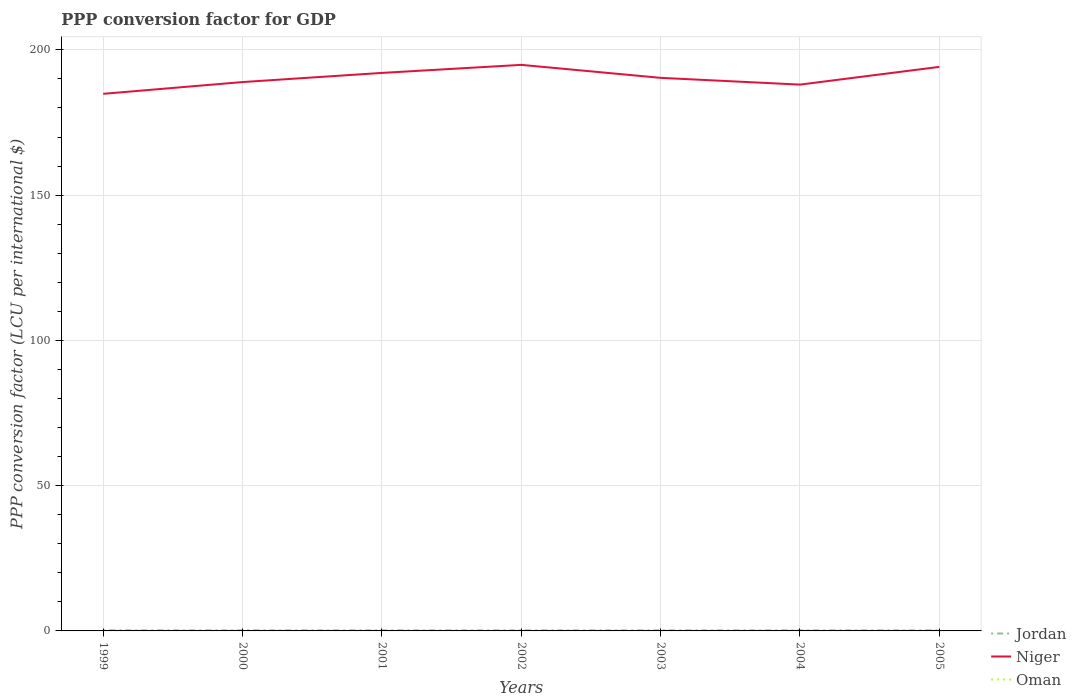How many different coloured lines are there?
Your response must be concise. 3. Is the number of lines equal to the number of legend labels?
Offer a terse response. Yes. Across all years, what is the maximum PPP conversion factor for GDP in Jordan?
Keep it short and to the point. 0.2. In which year was the PPP conversion factor for GDP in Niger maximum?
Offer a very short reply. 1999. What is the total PPP conversion factor for GDP in Niger in the graph?
Make the answer very short. -5.92. What is the difference between the highest and the second highest PPP conversion factor for GDP in Oman?
Make the answer very short. 0.05. Is the PPP conversion factor for GDP in Jordan strictly greater than the PPP conversion factor for GDP in Niger over the years?
Provide a succinct answer. Yes. Are the values on the major ticks of Y-axis written in scientific E-notation?
Ensure brevity in your answer.  No. Where does the legend appear in the graph?
Keep it short and to the point. Bottom right. How many legend labels are there?
Give a very brief answer. 3. How are the legend labels stacked?
Your response must be concise. Vertical. What is the title of the graph?
Provide a short and direct response. PPP conversion factor for GDP. Does "Aruba" appear as one of the legend labels in the graph?
Make the answer very short. No. What is the label or title of the X-axis?
Your answer should be compact. Years. What is the label or title of the Y-axis?
Keep it short and to the point. PPP conversion factor (LCU per international $). What is the PPP conversion factor (LCU per international $) in Jordan in 1999?
Provide a short and direct response. 0.21. What is the PPP conversion factor (LCU per international $) of Niger in 1999?
Ensure brevity in your answer.  184.87. What is the PPP conversion factor (LCU per international $) in Oman in 1999?
Ensure brevity in your answer.  0.08. What is the PPP conversion factor (LCU per international $) in Jordan in 2000?
Provide a short and direct response. 0.2. What is the PPP conversion factor (LCU per international $) in Niger in 2000?
Keep it short and to the point. 188.91. What is the PPP conversion factor (LCU per international $) in Oman in 2000?
Keep it short and to the point. 0.09. What is the PPP conversion factor (LCU per international $) of Jordan in 2001?
Your response must be concise. 0.2. What is the PPP conversion factor (LCU per international $) in Niger in 2001?
Offer a terse response. 192.06. What is the PPP conversion factor (LCU per international $) of Oman in 2001?
Provide a short and direct response. 0.09. What is the PPP conversion factor (LCU per international $) in Jordan in 2002?
Keep it short and to the point. 0.2. What is the PPP conversion factor (LCU per international $) of Niger in 2002?
Offer a very short reply. 194.83. What is the PPP conversion factor (LCU per international $) in Oman in 2002?
Offer a terse response. 0.09. What is the PPP conversion factor (LCU per international $) in Jordan in 2003?
Provide a succinct answer. 0.2. What is the PPP conversion factor (LCU per international $) in Niger in 2003?
Your answer should be very brief. 190.36. What is the PPP conversion factor (LCU per international $) of Oman in 2003?
Provide a short and direct response. 0.1. What is the PPP conversion factor (LCU per international $) in Jordan in 2004?
Your response must be concise. 0.2. What is the PPP conversion factor (LCU per international $) of Niger in 2004?
Give a very brief answer. 188.03. What is the PPP conversion factor (LCU per international $) in Oman in 2004?
Make the answer very short. 0.11. What is the PPP conversion factor (LCU per international $) of Jordan in 2005?
Your response must be concise. 0.2. What is the PPP conversion factor (LCU per international $) of Niger in 2005?
Ensure brevity in your answer.  194.14. What is the PPP conversion factor (LCU per international $) of Oman in 2005?
Ensure brevity in your answer.  0.13. Across all years, what is the maximum PPP conversion factor (LCU per international $) in Jordan?
Give a very brief answer. 0.21. Across all years, what is the maximum PPP conversion factor (LCU per international $) in Niger?
Keep it short and to the point. 194.83. Across all years, what is the maximum PPP conversion factor (LCU per international $) in Oman?
Your answer should be compact. 0.13. Across all years, what is the minimum PPP conversion factor (LCU per international $) in Jordan?
Provide a succinct answer. 0.2. Across all years, what is the minimum PPP conversion factor (LCU per international $) of Niger?
Ensure brevity in your answer.  184.87. Across all years, what is the minimum PPP conversion factor (LCU per international $) in Oman?
Make the answer very short. 0.08. What is the total PPP conversion factor (LCU per international $) in Jordan in the graph?
Offer a very short reply. 1.42. What is the total PPP conversion factor (LCU per international $) of Niger in the graph?
Provide a succinct answer. 1333.21. What is the total PPP conversion factor (LCU per international $) in Oman in the graph?
Your response must be concise. 0.69. What is the difference between the PPP conversion factor (LCU per international $) of Jordan in 1999 and that in 2000?
Provide a short and direct response. 0.01. What is the difference between the PPP conversion factor (LCU per international $) in Niger in 1999 and that in 2000?
Offer a very short reply. -4.05. What is the difference between the PPP conversion factor (LCU per international $) in Oman in 1999 and that in 2000?
Make the answer very short. -0.01. What is the difference between the PPP conversion factor (LCU per international $) of Jordan in 1999 and that in 2001?
Keep it short and to the point. 0.01. What is the difference between the PPP conversion factor (LCU per international $) in Niger in 1999 and that in 2001?
Offer a very short reply. -7.2. What is the difference between the PPP conversion factor (LCU per international $) in Oman in 1999 and that in 2001?
Your answer should be very brief. -0.01. What is the difference between the PPP conversion factor (LCU per international $) in Jordan in 1999 and that in 2002?
Your response must be concise. 0.01. What is the difference between the PPP conversion factor (LCU per international $) of Niger in 1999 and that in 2002?
Ensure brevity in your answer.  -9.96. What is the difference between the PPP conversion factor (LCU per international $) in Oman in 1999 and that in 2002?
Make the answer very short. -0.01. What is the difference between the PPP conversion factor (LCU per international $) in Jordan in 1999 and that in 2003?
Provide a succinct answer. 0.01. What is the difference between the PPP conversion factor (LCU per international $) of Niger in 1999 and that in 2003?
Give a very brief answer. -5.5. What is the difference between the PPP conversion factor (LCU per international $) of Oman in 1999 and that in 2003?
Provide a succinct answer. -0.02. What is the difference between the PPP conversion factor (LCU per international $) of Jordan in 1999 and that in 2004?
Your answer should be compact. 0.01. What is the difference between the PPP conversion factor (LCU per international $) in Niger in 1999 and that in 2004?
Provide a succinct answer. -3.17. What is the difference between the PPP conversion factor (LCU per international $) of Oman in 1999 and that in 2004?
Keep it short and to the point. -0.03. What is the difference between the PPP conversion factor (LCU per international $) of Jordan in 1999 and that in 2005?
Your response must be concise. 0.01. What is the difference between the PPP conversion factor (LCU per international $) in Niger in 1999 and that in 2005?
Keep it short and to the point. -9.28. What is the difference between the PPP conversion factor (LCU per international $) in Oman in 1999 and that in 2005?
Provide a short and direct response. -0.05. What is the difference between the PPP conversion factor (LCU per international $) of Jordan in 2000 and that in 2001?
Give a very brief answer. 0. What is the difference between the PPP conversion factor (LCU per international $) in Niger in 2000 and that in 2001?
Your answer should be compact. -3.15. What is the difference between the PPP conversion factor (LCU per international $) of Oman in 2000 and that in 2001?
Keep it short and to the point. 0.01. What is the difference between the PPP conversion factor (LCU per international $) in Jordan in 2000 and that in 2002?
Provide a short and direct response. 0. What is the difference between the PPP conversion factor (LCU per international $) of Niger in 2000 and that in 2002?
Your answer should be compact. -5.92. What is the difference between the PPP conversion factor (LCU per international $) of Oman in 2000 and that in 2002?
Make the answer very short. 0. What is the difference between the PPP conversion factor (LCU per international $) in Jordan in 2000 and that in 2003?
Your answer should be very brief. 0. What is the difference between the PPP conversion factor (LCU per international $) of Niger in 2000 and that in 2003?
Provide a short and direct response. -1.45. What is the difference between the PPP conversion factor (LCU per international $) of Oman in 2000 and that in 2003?
Offer a terse response. -0. What is the difference between the PPP conversion factor (LCU per international $) in Jordan in 2000 and that in 2004?
Ensure brevity in your answer.  0. What is the difference between the PPP conversion factor (LCU per international $) in Niger in 2000 and that in 2004?
Ensure brevity in your answer.  0.88. What is the difference between the PPP conversion factor (LCU per international $) in Oman in 2000 and that in 2004?
Offer a very short reply. -0.01. What is the difference between the PPP conversion factor (LCU per international $) of Jordan in 2000 and that in 2005?
Provide a short and direct response. 0.01. What is the difference between the PPP conversion factor (LCU per international $) of Niger in 2000 and that in 2005?
Keep it short and to the point. -5.23. What is the difference between the PPP conversion factor (LCU per international $) in Oman in 2000 and that in 2005?
Give a very brief answer. -0.03. What is the difference between the PPP conversion factor (LCU per international $) in Jordan in 2001 and that in 2002?
Ensure brevity in your answer.  0. What is the difference between the PPP conversion factor (LCU per international $) of Niger in 2001 and that in 2002?
Your answer should be very brief. -2.77. What is the difference between the PPP conversion factor (LCU per international $) of Oman in 2001 and that in 2002?
Provide a short and direct response. -0. What is the difference between the PPP conversion factor (LCU per international $) of Jordan in 2001 and that in 2003?
Ensure brevity in your answer.  0. What is the difference between the PPP conversion factor (LCU per international $) in Niger in 2001 and that in 2003?
Offer a very short reply. 1.7. What is the difference between the PPP conversion factor (LCU per international $) of Oman in 2001 and that in 2003?
Provide a short and direct response. -0.01. What is the difference between the PPP conversion factor (LCU per international $) in Jordan in 2001 and that in 2004?
Ensure brevity in your answer.  0. What is the difference between the PPP conversion factor (LCU per international $) in Niger in 2001 and that in 2004?
Provide a succinct answer. 4.03. What is the difference between the PPP conversion factor (LCU per international $) in Oman in 2001 and that in 2004?
Offer a terse response. -0.02. What is the difference between the PPP conversion factor (LCU per international $) of Jordan in 2001 and that in 2005?
Ensure brevity in your answer.  0. What is the difference between the PPP conversion factor (LCU per international $) in Niger in 2001 and that in 2005?
Ensure brevity in your answer.  -2.08. What is the difference between the PPP conversion factor (LCU per international $) in Oman in 2001 and that in 2005?
Your response must be concise. -0.04. What is the difference between the PPP conversion factor (LCU per international $) in Jordan in 2002 and that in 2003?
Provide a succinct answer. -0. What is the difference between the PPP conversion factor (LCU per international $) in Niger in 2002 and that in 2003?
Offer a terse response. 4.47. What is the difference between the PPP conversion factor (LCU per international $) in Oman in 2002 and that in 2003?
Keep it short and to the point. -0.01. What is the difference between the PPP conversion factor (LCU per international $) in Jordan in 2002 and that in 2004?
Ensure brevity in your answer.  -0. What is the difference between the PPP conversion factor (LCU per international $) in Niger in 2002 and that in 2004?
Provide a succinct answer. 6.8. What is the difference between the PPP conversion factor (LCU per international $) of Oman in 2002 and that in 2004?
Your answer should be very brief. -0.02. What is the difference between the PPP conversion factor (LCU per international $) in Jordan in 2002 and that in 2005?
Your answer should be compact. 0. What is the difference between the PPP conversion factor (LCU per international $) of Niger in 2002 and that in 2005?
Your answer should be very brief. 0.69. What is the difference between the PPP conversion factor (LCU per international $) in Oman in 2002 and that in 2005?
Offer a terse response. -0.04. What is the difference between the PPP conversion factor (LCU per international $) of Jordan in 2003 and that in 2004?
Your response must be concise. -0. What is the difference between the PPP conversion factor (LCU per international $) of Niger in 2003 and that in 2004?
Ensure brevity in your answer.  2.33. What is the difference between the PPP conversion factor (LCU per international $) of Oman in 2003 and that in 2004?
Keep it short and to the point. -0.01. What is the difference between the PPP conversion factor (LCU per international $) in Jordan in 2003 and that in 2005?
Your answer should be very brief. 0. What is the difference between the PPP conversion factor (LCU per international $) in Niger in 2003 and that in 2005?
Your answer should be compact. -3.78. What is the difference between the PPP conversion factor (LCU per international $) in Oman in 2003 and that in 2005?
Offer a very short reply. -0.03. What is the difference between the PPP conversion factor (LCU per international $) of Jordan in 2004 and that in 2005?
Make the answer very short. 0. What is the difference between the PPP conversion factor (LCU per international $) of Niger in 2004 and that in 2005?
Your response must be concise. -6.11. What is the difference between the PPP conversion factor (LCU per international $) in Oman in 2004 and that in 2005?
Offer a terse response. -0.02. What is the difference between the PPP conversion factor (LCU per international $) of Jordan in 1999 and the PPP conversion factor (LCU per international $) of Niger in 2000?
Provide a succinct answer. -188.7. What is the difference between the PPP conversion factor (LCU per international $) of Jordan in 1999 and the PPP conversion factor (LCU per international $) of Oman in 2000?
Keep it short and to the point. 0.12. What is the difference between the PPP conversion factor (LCU per international $) of Niger in 1999 and the PPP conversion factor (LCU per international $) of Oman in 2000?
Provide a succinct answer. 184.77. What is the difference between the PPP conversion factor (LCU per international $) in Jordan in 1999 and the PPP conversion factor (LCU per international $) in Niger in 2001?
Your answer should be very brief. -191.85. What is the difference between the PPP conversion factor (LCU per international $) in Jordan in 1999 and the PPP conversion factor (LCU per international $) in Oman in 2001?
Ensure brevity in your answer.  0.12. What is the difference between the PPP conversion factor (LCU per international $) of Niger in 1999 and the PPP conversion factor (LCU per international $) of Oman in 2001?
Your answer should be very brief. 184.78. What is the difference between the PPP conversion factor (LCU per international $) in Jordan in 1999 and the PPP conversion factor (LCU per international $) in Niger in 2002?
Offer a very short reply. -194.62. What is the difference between the PPP conversion factor (LCU per international $) in Jordan in 1999 and the PPP conversion factor (LCU per international $) in Oman in 2002?
Provide a short and direct response. 0.12. What is the difference between the PPP conversion factor (LCU per international $) in Niger in 1999 and the PPP conversion factor (LCU per international $) in Oman in 2002?
Offer a very short reply. 184.77. What is the difference between the PPP conversion factor (LCU per international $) of Jordan in 1999 and the PPP conversion factor (LCU per international $) of Niger in 2003?
Your answer should be compact. -190.15. What is the difference between the PPP conversion factor (LCU per international $) in Jordan in 1999 and the PPP conversion factor (LCU per international $) in Oman in 2003?
Ensure brevity in your answer.  0.11. What is the difference between the PPP conversion factor (LCU per international $) in Niger in 1999 and the PPP conversion factor (LCU per international $) in Oman in 2003?
Your answer should be compact. 184.77. What is the difference between the PPP conversion factor (LCU per international $) of Jordan in 1999 and the PPP conversion factor (LCU per international $) of Niger in 2004?
Keep it short and to the point. -187.82. What is the difference between the PPP conversion factor (LCU per international $) in Jordan in 1999 and the PPP conversion factor (LCU per international $) in Oman in 2004?
Your answer should be compact. 0.1. What is the difference between the PPP conversion factor (LCU per international $) in Niger in 1999 and the PPP conversion factor (LCU per international $) in Oman in 2004?
Offer a terse response. 184.76. What is the difference between the PPP conversion factor (LCU per international $) of Jordan in 1999 and the PPP conversion factor (LCU per international $) of Niger in 2005?
Provide a short and direct response. -193.93. What is the difference between the PPP conversion factor (LCU per international $) of Jordan in 1999 and the PPP conversion factor (LCU per international $) of Oman in 2005?
Provide a short and direct response. 0.08. What is the difference between the PPP conversion factor (LCU per international $) of Niger in 1999 and the PPP conversion factor (LCU per international $) of Oman in 2005?
Your response must be concise. 184.74. What is the difference between the PPP conversion factor (LCU per international $) in Jordan in 2000 and the PPP conversion factor (LCU per international $) in Niger in 2001?
Provide a short and direct response. -191.86. What is the difference between the PPP conversion factor (LCU per international $) in Jordan in 2000 and the PPP conversion factor (LCU per international $) in Oman in 2001?
Give a very brief answer. 0.12. What is the difference between the PPP conversion factor (LCU per international $) in Niger in 2000 and the PPP conversion factor (LCU per international $) in Oman in 2001?
Offer a terse response. 188.83. What is the difference between the PPP conversion factor (LCU per international $) in Jordan in 2000 and the PPP conversion factor (LCU per international $) in Niger in 2002?
Keep it short and to the point. -194.63. What is the difference between the PPP conversion factor (LCU per international $) of Jordan in 2000 and the PPP conversion factor (LCU per international $) of Oman in 2002?
Ensure brevity in your answer.  0.11. What is the difference between the PPP conversion factor (LCU per international $) in Niger in 2000 and the PPP conversion factor (LCU per international $) in Oman in 2002?
Offer a very short reply. 188.82. What is the difference between the PPP conversion factor (LCU per international $) of Jordan in 2000 and the PPP conversion factor (LCU per international $) of Niger in 2003?
Give a very brief answer. -190.16. What is the difference between the PPP conversion factor (LCU per international $) in Jordan in 2000 and the PPP conversion factor (LCU per international $) in Oman in 2003?
Offer a very short reply. 0.11. What is the difference between the PPP conversion factor (LCU per international $) of Niger in 2000 and the PPP conversion factor (LCU per international $) of Oman in 2003?
Offer a very short reply. 188.82. What is the difference between the PPP conversion factor (LCU per international $) in Jordan in 2000 and the PPP conversion factor (LCU per international $) in Niger in 2004?
Make the answer very short. -187.83. What is the difference between the PPP conversion factor (LCU per international $) in Jordan in 2000 and the PPP conversion factor (LCU per international $) in Oman in 2004?
Your answer should be compact. 0.1. What is the difference between the PPP conversion factor (LCU per international $) of Niger in 2000 and the PPP conversion factor (LCU per international $) of Oman in 2004?
Make the answer very short. 188.81. What is the difference between the PPP conversion factor (LCU per international $) in Jordan in 2000 and the PPP conversion factor (LCU per international $) in Niger in 2005?
Your answer should be very brief. -193.94. What is the difference between the PPP conversion factor (LCU per international $) of Jordan in 2000 and the PPP conversion factor (LCU per international $) of Oman in 2005?
Keep it short and to the point. 0.08. What is the difference between the PPP conversion factor (LCU per international $) in Niger in 2000 and the PPP conversion factor (LCU per international $) in Oman in 2005?
Keep it short and to the point. 188.79. What is the difference between the PPP conversion factor (LCU per international $) of Jordan in 2001 and the PPP conversion factor (LCU per international $) of Niger in 2002?
Make the answer very short. -194.63. What is the difference between the PPP conversion factor (LCU per international $) of Jordan in 2001 and the PPP conversion factor (LCU per international $) of Oman in 2002?
Give a very brief answer. 0.11. What is the difference between the PPP conversion factor (LCU per international $) of Niger in 2001 and the PPP conversion factor (LCU per international $) of Oman in 2002?
Your answer should be very brief. 191.97. What is the difference between the PPP conversion factor (LCU per international $) in Jordan in 2001 and the PPP conversion factor (LCU per international $) in Niger in 2003?
Make the answer very short. -190.16. What is the difference between the PPP conversion factor (LCU per international $) of Jordan in 2001 and the PPP conversion factor (LCU per international $) of Oman in 2003?
Offer a terse response. 0.1. What is the difference between the PPP conversion factor (LCU per international $) in Niger in 2001 and the PPP conversion factor (LCU per international $) in Oman in 2003?
Keep it short and to the point. 191.96. What is the difference between the PPP conversion factor (LCU per international $) of Jordan in 2001 and the PPP conversion factor (LCU per international $) of Niger in 2004?
Give a very brief answer. -187.83. What is the difference between the PPP conversion factor (LCU per international $) of Jordan in 2001 and the PPP conversion factor (LCU per international $) of Oman in 2004?
Ensure brevity in your answer.  0.09. What is the difference between the PPP conversion factor (LCU per international $) of Niger in 2001 and the PPP conversion factor (LCU per international $) of Oman in 2004?
Ensure brevity in your answer.  191.95. What is the difference between the PPP conversion factor (LCU per international $) of Jordan in 2001 and the PPP conversion factor (LCU per international $) of Niger in 2005?
Give a very brief answer. -193.94. What is the difference between the PPP conversion factor (LCU per international $) in Jordan in 2001 and the PPP conversion factor (LCU per international $) in Oman in 2005?
Keep it short and to the point. 0.07. What is the difference between the PPP conversion factor (LCU per international $) of Niger in 2001 and the PPP conversion factor (LCU per international $) of Oman in 2005?
Your response must be concise. 191.93. What is the difference between the PPP conversion factor (LCU per international $) of Jordan in 2002 and the PPP conversion factor (LCU per international $) of Niger in 2003?
Your answer should be compact. -190.16. What is the difference between the PPP conversion factor (LCU per international $) in Jordan in 2002 and the PPP conversion factor (LCU per international $) in Oman in 2003?
Your answer should be very brief. 0.1. What is the difference between the PPP conversion factor (LCU per international $) in Niger in 2002 and the PPP conversion factor (LCU per international $) in Oman in 2003?
Your answer should be compact. 194.73. What is the difference between the PPP conversion factor (LCU per international $) of Jordan in 2002 and the PPP conversion factor (LCU per international $) of Niger in 2004?
Give a very brief answer. -187.83. What is the difference between the PPP conversion factor (LCU per international $) in Jordan in 2002 and the PPP conversion factor (LCU per international $) in Oman in 2004?
Your answer should be compact. 0.09. What is the difference between the PPP conversion factor (LCU per international $) in Niger in 2002 and the PPP conversion factor (LCU per international $) in Oman in 2004?
Keep it short and to the point. 194.72. What is the difference between the PPP conversion factor (LCU per international $) of Jordan in 2002 and the PPP conversion factor (LCU per international $) of Niger in 2005?
Provide a short and direct response. -193.94. What is the difference between the PPP conversion factor (LCU per international $) of Jordan in 2002 and the PPP conversion factor (LCU per international $) of Oman in 2005?
Offer a terse response. 0.07. What is the difference between the PPP conversion factor (LCU per international $) of Niger in 2002 and the PPP conversion factor (LCU per international $) of Oman in 2005?
Offer a terse response. 194.7. What is the difference between the PPP conversion factor (LCU per international $) of Jordan in 2003 and the PPP conversion factor (LCU per international $) of Niger in 2004?
Offer a very short reply. -187.83. What is the difference between the PPP conversion factor (LCU per international $) of Jordan in 2003 and the PPP conversion factor (LCU per international $) of Oman in 2004?
Your answer should be very brief. 0.09. What is the difference between the PPP conversion factor (LCU per international $) in Niger in 2003 and the PPP conversion factor (LCU per international $) in Oman in 2004?
Provide a succinct answer. 190.26. What is the difference between the PPP conversion factor (LCU per international $) in Jordan in 2003 and the PPP conversion factor (LCU per international $) in Niger in 2005?
Your response must be concise. -193.94. What is the difference between the PPP conversion factor (LCU per international $) of Jordan in 2003 and the PPP conversion factor (LCU per international $) of Oman in 2005?
Provide a succinct answer. 0.07. What is the difference between the PPP conversion factor (LCU per international $) of Niger in 2003 and the PPP conversion factor (LCU per international $) of Oman in 2005?
Your answer should be compact. 190.24. What is the difference between the PPP conversion factor (LCU per international $) in Jordan in 2004 and the PPP conversion factor (LCU per international $) in Niger in 2005?
Provide a succinct answer. -193.94. What is the difference between the PPP conversion factor (LCU per international $) in Jordan in 2004 and the PPP conversion factor (LCU per international $) in Oman in 2005?
Give a very brief answer. 0.07. What is the difference between the PPP conversion factor (LCU per international $) of Niger in 2004 and the PPP conversion factor (LCU per international $) of Oman in 2005?
Provide a succinct answer. 187.91. What is the average PPP conversion factor (LCU per international $) in Jordan per year?
Make the answer very short. 0.2. What is the average PPP conversion factor (LCU per international $) of Niger per year?
Ensure brevity in your answer.  190.46. What is the average PPP conversion factor (LCU per international $) in Oman per year?
Give a very brief answer. 0.1. In the year 1999, what is the difference between the PPP conversion factor (LCU per international $) of Jordan and PPP conversion factor (LCU per international $) of Niger?
Offer a very short reply. -184.66. In the year 1999, what is the difference between the PPP conversion factor (LCU per international $) in Jordan and PPP conversion factor (LCU per international $) in Oman?
Offer a very short reply. 0.13. In the year 1999, what is the difference between the PPP conversion factor (LCU per international $) of Niger and PPP conversion factor (LCU per international $) of Oman?
Offer a very short reply. 184.78. In the year 2000, what is the difference between the PPP conversion factor (LCU per international $) of Jordan and PPP conversion factor (LCU per international $) of Niger?
Ensure brevity in your answer.  -188.71. In the year 2000, what is the difference between the PPP conversion factor (LCU per international $) of Jordan and PPP conversion factor (LCU per international $) of Oman?
Offer a very short reply. 0.11. In the year 2000, what is the difference between the PPP conversion factor (LCU per international $) in Niger and PPP conversion factor (LCU per international $) in Oman?
Your response must be concise. 188.82. In the year 2001, what is the difference between the PPP conversion factor (LCU per international $) of Jordan and PPP conversion factor (LCU per international $) of Niger?
Your answer should be very brief. -191.86. In the year 2001, what is the difference between the PPP conversion factor (LCU per international $) in Jordan and PPP conversion factor (LCU per international $) in Oman?
Give a very brief answer. 0.11. In the year 2001, what is the difference between the PPP conversion factor (LCU per international $) of Niger and PPP conversion factor (LCU per international $) of Oman?
Keep it short and to the point. 191.97. In the year 2002, what is the difference between the PPP conversion factor (LCU per international $) in Jordan and PPP conversion factor (LCU per international $) in Niger?
Provide a short and direct response. -194.63. In the year 2002, what is the difference between the PPP conversion factor (LCU per international $) of Jordan and PPP conversion factor (LCU per international $) of Oman?
Offer a terse response. 0.11. In the year 2002, what is the difference between the PPP conversion factor (LCU per international $) of Niger and PPP conversion factor (LCU per international $) of Oman?
Offer a very short reply. 194.74. In the year 2003, what is the difference between the PPP conversion factor (LCU per international $) in Jordan and PPP conversion factor (LCU per international $) in Niger?
Keep it short and to the point. -190.16. In the year 2003, what is the difference between the PPP conversion factor (LCU per international $) of Jordan and PPP conversion factor (LCU per international $) of Oman?
Make the answer very short. 0.1. In the year 2003, what is the difference between the PPP conversion factor (LCU per international $) in Niger and PPP conversion factor (LCU per international $) in Oman?
Ensure brevity in your answer.  190.27. In the year 2004, what is the difference between the PPP conversion factor (LCU per international $) in Jordan and PPP conversion factor (LCU per international $) in Niger?
Provide a short and direct response. -187.83. In the year 2004, what is the difference between the PPP conversion factor (LCU per international $) in Jordan and PPP conversion factor (LCU per international $) in Oman?
Make the answer very short. 0.09. In the year 2004, what is the difference between the PPP conversion factor (LCU per international $) in Niger and PPP conversion factor (LCU per international $) in Oman?
Ensure brevity in your answer.  187.93. In the year 2005, what is the difference between the PPP conversion factor (LCU per international $) of Jordan and PPP conversion factor (LCU per international $) of Niger?
Offer a very short reply. -193.94. In the year 2005, what is the difference between the PPP conversion factor (LCU per international $) of Jordan and PPP conversion factor (LCU per international $) of Oman?
Make the answer very short. 0.07. In the year 2005, what is the difference between the PPP conversion factor (LCU per international $) in Niger and PPP conversion factor (LCU per international $) in Oman?
Offer a very short reply. 194.01. What is the ratio of the PPP conversion factor (LCU per international $) in Jordan in 1999 to that in 2000?
Provide a short and direct response. 1.03. What is the ratio of the PPP conversion factor (LCU per international $) in Niger in 1999 to that in 2000?
Your response must be concise. 0.98. What is the ratio of the PPP conversion factor (LCU per international $) in Oman in 1999 to that in 2000?
Offer a terse response. 0.87. What is the ratio of the PPP conversion factor (LCU per international $) in Jordan in 1999 to that in 2001?
Ensure brevity in your answer.  1.04. What is the ratio of the PPP conversion factor (LCU per international $) of Niger in 1999 to that in 2001?
Offer a very short reply. 0.96. What is the ratio of the PPP conversion factor (LCU per international $) of Oman in 1999 to that in 2001?
Your answer should be very brief. 0.93. What is the ratio of the PPP conversion factor (LCU per international $) in Jordan in 1999 to that in 2002?
Give a very brief answer. 1.05. What is the ratio of the PPP conversion factor (LCU per international $) of Niger in 1999 to that in 2002?
Your answer should be very brief. 0.95. What is the ratio of the PPP conversion factor (LCU per international $) of Oman in 1999 to that in 2002?
Ensure brevity in your answer.  0.9. What is the ratio of the PPP conversion factor (LCU per international $) of Jordan in 1999 to that in 2003?
Keep it short and to the point. 1.05. What is the ratio of the PPP conversion factor (LCU per international $) of Niger in 1999 to that in 2003?
Your response must be concise. 0.97. What is the ratio of the PPP conversion factor (LCU per international $) in Oman in 1999 to that in 2003?
Your answer should be very brief. 0.83. What is the ratio of the PPP conversion factor (LCU per international $) of Jordan in 1999 to that in 2004?
Your response must be concise. 1.04. What is the ratio of the PPP conversion factor (LCU per international $) of Niger in 1999 to that in 2004?
Your response must be concise. 0.98. What is the ratio of the PPP conversion factor (LCU per international $) in Oman in 1999 to that in 2004?
Your answer should be very brief. 0.76. What is the ratio of the PPP conversion factor (LCU per international $) in Jordan in 1999 to that in 2005?
Your answer should be very brief. 1.06. What is the ratio of the PPP conversion factor (LCU per international $) in Niger in 1999 to that in 2005?
Keep it short and to the point. 0.95. What is the ratio of the PPP conversion factor (LCU per international $) of Oman in 1999 to that in 2005?
Your answer should be compact. 0.64. What is the ratio of the PPP conversion factor (LCU per international $) in Jordan in 2000 to that in 2001?
Your response must be concise. 1.01. What is the ratio of the PPP conversion factor (LCU per international $) in Niger in 2000 to that in 2001?
Provide a short and direct response. 0.98. What is the ratio of the PPP conversion factor (LCU per international $) in Oman in 2000 to that in 2001?
Your response must be concise. 1.07. What is the ratio of the PPP conversion factor (LCU per international $) of Jordan in 2000 to that in 2002?
Make the answer very short. 1.02. What is the ratio of the PPP conversion factor (LCU per international $) of Niger in 2000 to that in 2002?
Make the answer very short. 0.97. What is the ratio of the PPP conversion factor (LCU per international $) of Oman in 2000 to that in 2002?
Offer a terse response. 1.04. What is the ratio of the PPP conversion factor (LCU per international $) in Jordan in 2000 to that in 2003?
Your answer should be very brief. 1.02. What is the ratio of the PPP conversion factor (LCU per international $) of Oman in 2000 to that in 2003?
Provide a short and direct response. 0.96. What is the ratio of the PPP conversion factor (LCU per international $) of Jordan in 2000 to that in 2004?
Your answer should be compact. 1.02. What is the ratio of the PPP conversion factor (LCU per international $) in Niger in 2000 to that in 2004?
Keep it short and to the point. 1. What is the ratio of the PPP conversion factor (LCU per international $) in Oman in 2000 to that in 2004?
Your answer should be compact. 0.87. What is the ratio of the PPP conversion factor (LCU per international $) of Jordan in 2000 to that in 2005?
Your answer should be compact. 1.03. What is the ratio of the PPP conversion factor (LCU per international $) of Niger in 2000 to that in 2005?
Make the answer very short. 0.97. What is the ratio of the PPP conversion factor (LCU per international $) in Oman in 2000 to that in 2005?
Offer a very short reply. 0.74. What is the ratio of the PPP conversion factor (LCU per international $) of Jordan in 2001 to that in 2002?
Provide a short and direct response. 1.01. What is the ratio of the PPP conversion factor (LCU per international $) of Niger in 2001 to that in 2002?
Keep it short and to the point. 0.99. What is the ratio of the PPP conversion factor (LCU per international $) of Oman in 2001 to that in 2002?
Give a very brief answer. 0.97. What is the ratio of the PPP conversion factor (LCU per international $) of Niger in 2001 to that in 2003?
Offer a very short reply. 1.01. What is the ratio of the PPP conversion factor (LCU per international $) in Oman in 2001 to that in 2003?
Provide a short and direct response. 0.9. What is the ratio of the PPP conversion factor (LCU per international $) in Niger in 2001 to that in 2004?
Keep it short and to the point. 1.02. What is the ratio of the PPP conversion factor (LCU per international $) of Oman in 2001 to that in 2004?
Provide a short and direct response. 0.81. What is the ratio of the PPP conversion factor (LCU per international $) in Jordan in 2001 to that in 2005?
Offer a very short reply. 1.01. What is the ratio of the PPP conversion factor (LCU per international $) of Niger in 2001 to that in 2005?
Offer a terse response. 0.99. What is the ratio of the PPP conversion factor (LCU per international $) in Oman in 2001 to that in 2005?
Keep it short and to the point. 0.69. What is the ratio of the PPP conversion factor (LCU per international $) in Jordan in 2002 to that in 2003?
Provide a short and direct response. 1. What is the ratio of the PPP conversion factor (LCU per international $) of Niger in 2002 to that in 2003?
Provide a short and direct response. 1.02. What is the ratio of the PPP conversion factor (LCU per international $) in Oman in 2002 to that in 2003?
Offer a very short reply. 0.92. What is the ratio of the PPP conversion factor (LCU per international $) in Jordan in 2002 to that in 2004?
Keep it short and to the point. 1. What is the ratio of the PPP conversion factor (LCU per international $) in Niger in 2002 to that in 2004?
Your answer should be compact. 1.04. What is the ratio of the PPP conversion factor (LCU per international $) of Oman in 2002 to that in 2004?
Make the answer very short. 0.84. What is the ratio of the PPP conversion factor (LCU per international $) of Jordan in 2002 to that in 2005?
Give a very brief answer. 1.01. What is the ratio of the PPP conversion factor (LCU per international $) in Oman in 2002 to that in 2005?
Your answer should be compact. 0.71. What is the ratio of the PPP conversion factor (LCU per international $) of Jordan in 2003 to that in 2004?
Give a very brief answer. 1. What is the ratio of the PPP conversion factor (LCU per international $) of Niger in 2003 to that in 2004?
Provide a short and direct response. 1.01. What is the ratio of the PPP conversion factor (LCU per international $) of Oman in 2003 to that in 2004?
Make the answer very short. 0.91. What is the ratio of the PPP conversion factor (LCU per international $) of Jordan in 2003 to that in 2005?
Give a very brief answer. 1.01. What is the ratio of the PPP conversion factor (LCU per international $) in Niger in 2003 to that in 2005?
Offer a terse response. 0.98. What is the ratio of the PPP conversion factor (LCU per international $) of Oman in 2003 to that in 2005?
Ensure brevity in your answer.  0.77. What is the ratio of the PPP conversion factor (LCU per international $) of Jordan in 2004 to that in 2005?
Ensure brevity in your answer.  1.01. What is the ratio of the PPP conversion factor (LCU per international $) in Niger in 2004 to that in 2005?
Make the answer very short. 0.97. What is the ratio of the PPP conversion factor (LCU per international $) of Oman in 2004 to that in 2005?
Provide a succinct answer. 0.84. What is the difference between the highest and the second highest PPP conversion factor (LCU per international $) in Jordan?
Offer a terse response. 0.01. What is the difference between the highest and the second highest PPP conversion factor (LCU per international $) of Niger?
Offer a very short reply. 0.69. What is the difference between the highest and the second highest PPP conversion factor (LCU per international $) in Oman?
Your answer should be compact. 0.02. What is the difference between the highest and the lowest PPP conversion factor (LCU per international $) of Jordan?
Ensure brevity in your answer.  0.01. What is the difference between the highest and the lowest PPP conversion factor (LCU per international $) of Niger?
Offer a very short reply. 9.96. What is the difference between the highest and the lowest PPP conversion factor (LCU per international $) in Oman?
Give a very brief answer. 0.05. 